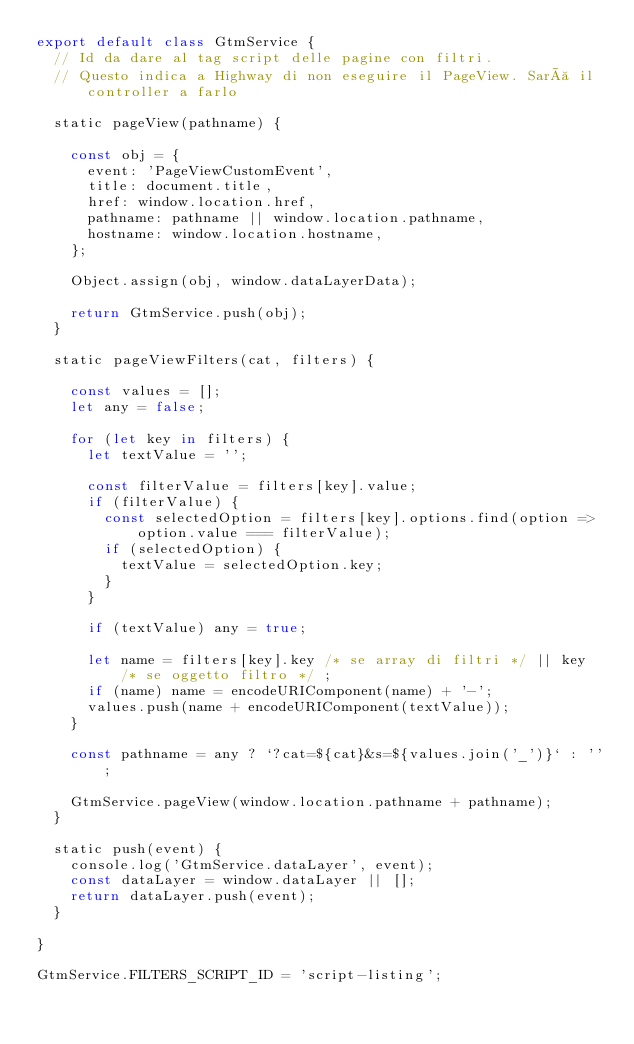<code> <loc_0><loc_0><loc_500><loc_500><_JavaScript_>export default class GtmService {
	// Id da dare al tag script delle pagine con filtri.
	// Questo indica a Highway di non eseguire il PageView. Sarà il controller a farlo

	static pageView(pathname) {

		const obj = {
			event: 'PageViewCustomEvent',
			title: document.title,
			href: window.location.href,
			pathname: pathname || window.location.pathname,
			hostname: window.location.hostname,
		};

		Object.assign(obj, window.dataLayerData);

		return GtmService.push(obj);
	}

	static pageViewFilters(cat, filters) {

		const values = [];
		let any = false;

		for (let key in filters) {
			let textValue = '';

			const filterValue = filters[key].value;
			if (filterValue) {
				const selectedOption = filters[key].options.find(option => option.value === filterValue);
				if (selectedOption) {
					textValue = selectedOption.key;
				}
			}

			if (textValue) any = true;

			let name = filters[key].key /* se array di filtri */ || key /* se oggetto filtro */ ;
			if (name) name = encodeURIComponent(name) + '-';
			values.push(name + encodeURIComponent(textValue));
		}

		const pathname = any ? `?cat=${cat}&s=${values.join('_')}` : '';

		GtmService.pageView(window.location.pathname + pathname);
	}

	static push(event) {
		console.log('GtmService.dataLayer', event);
		const dataLayer = window.dataLayer || [];
		return dataLayer.push(event);
	}

}

GtmService.FILTERS_SCRIPT_ID = 'script-listing';
</code> 